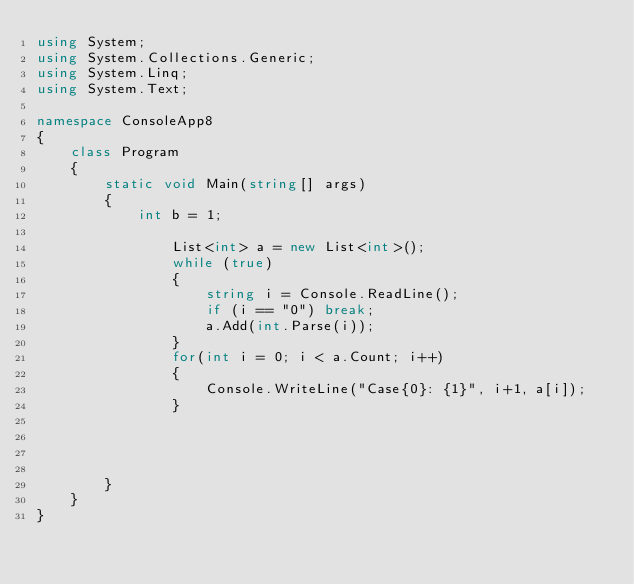<code> <loc_0><loc_0><loc_500><loc_500><_C#_>using System;
using System.Collections.Generic;
using System.Linq;
using System.Text;

namespace ConsoleApp8
{
    class Program
    {
        static void Main(string[] args)
        {
            int b = 1;
               
                List<int> a = new List<int>();
                while (true)
                {
                    string i = Console.ReadLine();
                    if (i == "0") break;
                    a.Add(int.Parse(i));
                }
                for(int i = 0; i < a.Count; i++)
                {
                    Console.WriteLine("Case{0}: {1}", i+1, a[i]);
                }




        }
    }
}</code> 